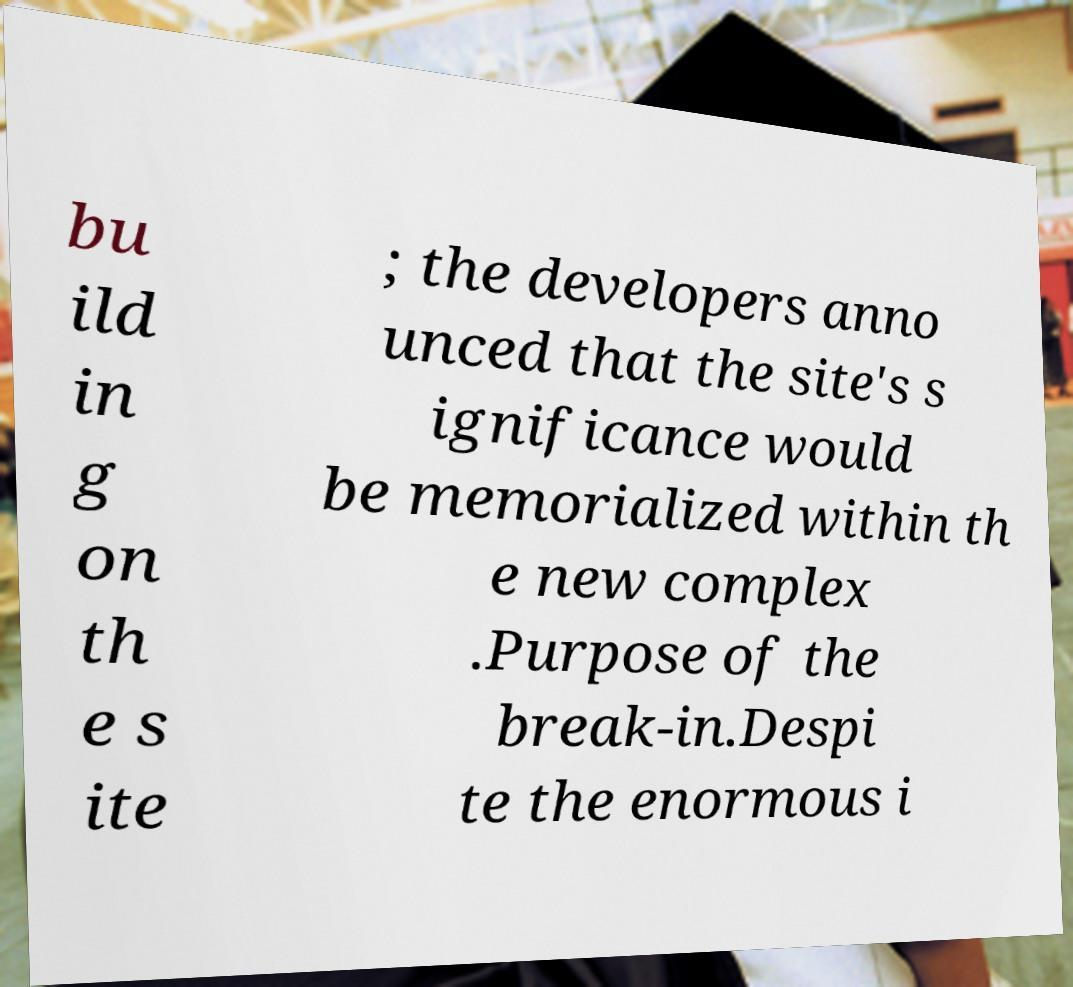For documentation purposes, I need the text within this image transcribed. Could you provide that? bu ild in g on th e s ite ; the developers anno unced that the site's s ignificance would be memorialized within th e new complex .Purpose of the break-in.Despi te the enormous i 